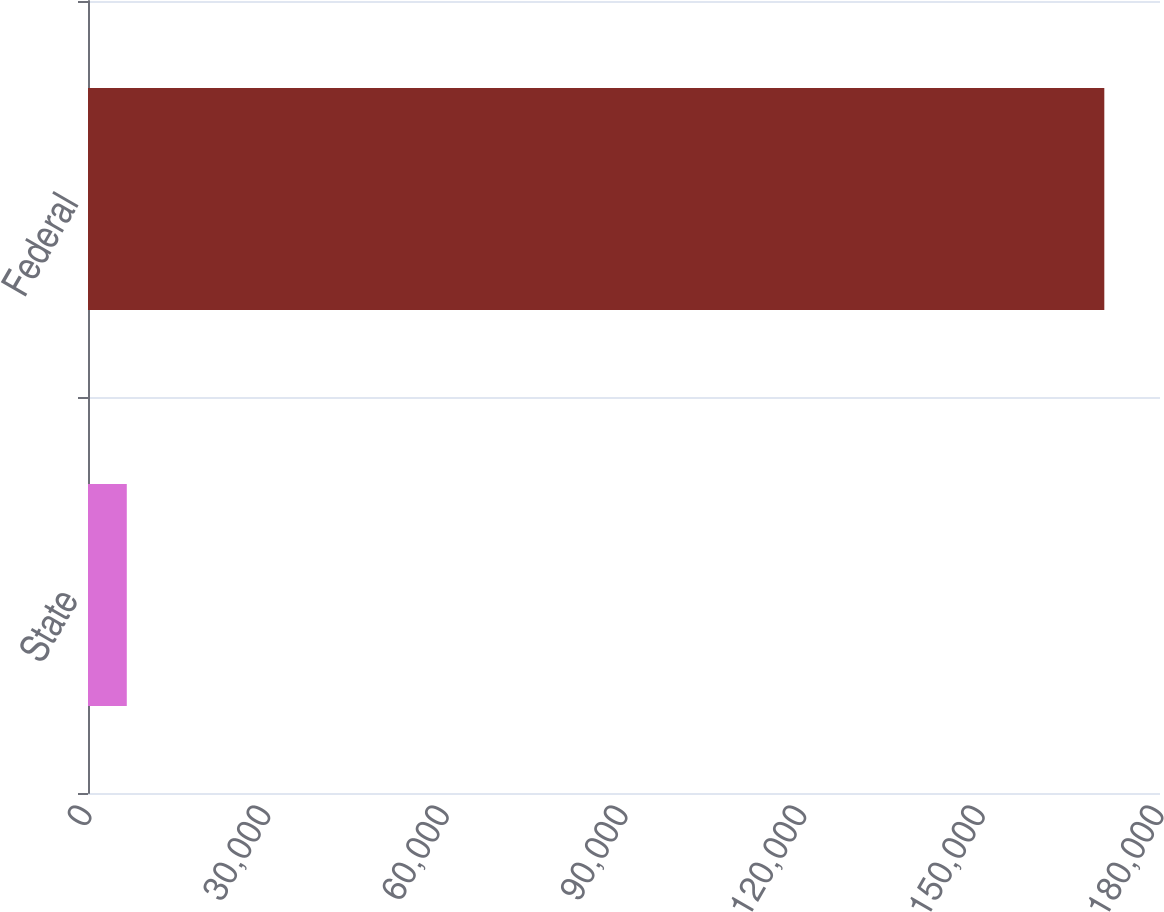<chart> <loc_0><loc_0><loc_500><loc_500><bar_chart><fcel>State<fcel>Federal<nl><fcel>6513<fcel>170649<nl></chart> 